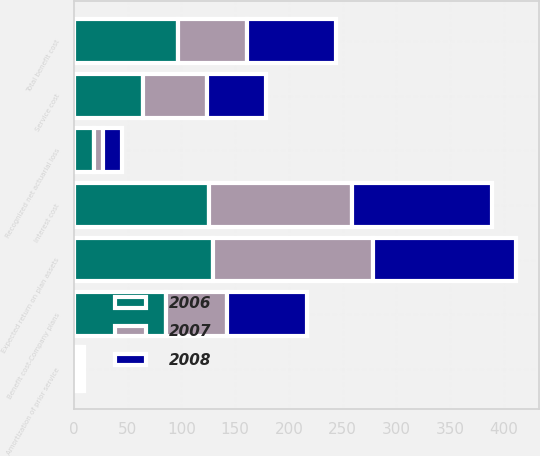Convert chart to OTSL. <chart><loc_0><loc_0><loc_500><loc_500><stacked_bar_chart><ecel><fcel>Service cost<fcel>Interest cost<fcel>Expected return on plan assets<fcel>Amortization of prior service<fcel>Recognized net actuarial loss<fcel>Benefit cost-Company plans<fcel>Total benefit cost<nl><fcel>2007<fcel>59.9<fcel>133.3<fcel>148.6<fcel>3.4<fcel>8.4<fcel>56.4<fcel>64.9<nl><fcel>2008<fcel>55.4<fcel>130.6<fcel>133.7<fcel>3.3<fcel>17.6<fcel>75.1<fcel>82.8<nl><fcel>2006<fcel>63.7<fcel>125.6<fcel>129.6<fcel>2.7<fcel>18.9<fcel>85.8<fcel>96.3<nl></chart> 